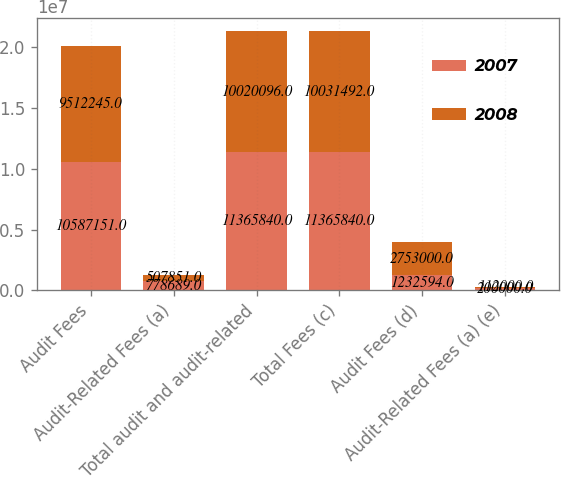Convert chart. <chart><loc_0><loc_0><loc_500><loc_500><stacked_bar_chart><ecel><fcel>Audit Fees<fcel>Audit-Related Fees (a)<fcel>Total audit and audit-related<fcel>Total Fees (c)<fcel>Audit Fees (d)<fcel>Audit-Related Fees (a) (e)<nl><fcel>2007<fcel>1.05872e+07<fcel>778689<fcel>1.13658e+07<fcel>1.13658e+07<fcel>1.23259e+06<fcel>200000<nl><fcel>2008<fcel>9.51224e+06<fcel>507851<fcel>1.00201e+07<fcel>1.00315e+07<fcel>2.753e+06<fcel>112000<nl></chart> 